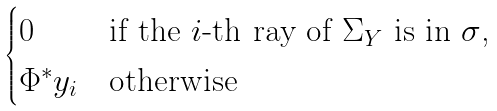Convert formula to latex. <formula><loc_0><loc_0><loc_500><loc_500>\begin{cases} 0 & \text {if the $i$-th ray of $\Sigma_{Y}$ is in $\sigma$,} \\ \Phi ^ { * } y _ { i } & \text {otherwise} \end{cases}</formula> 